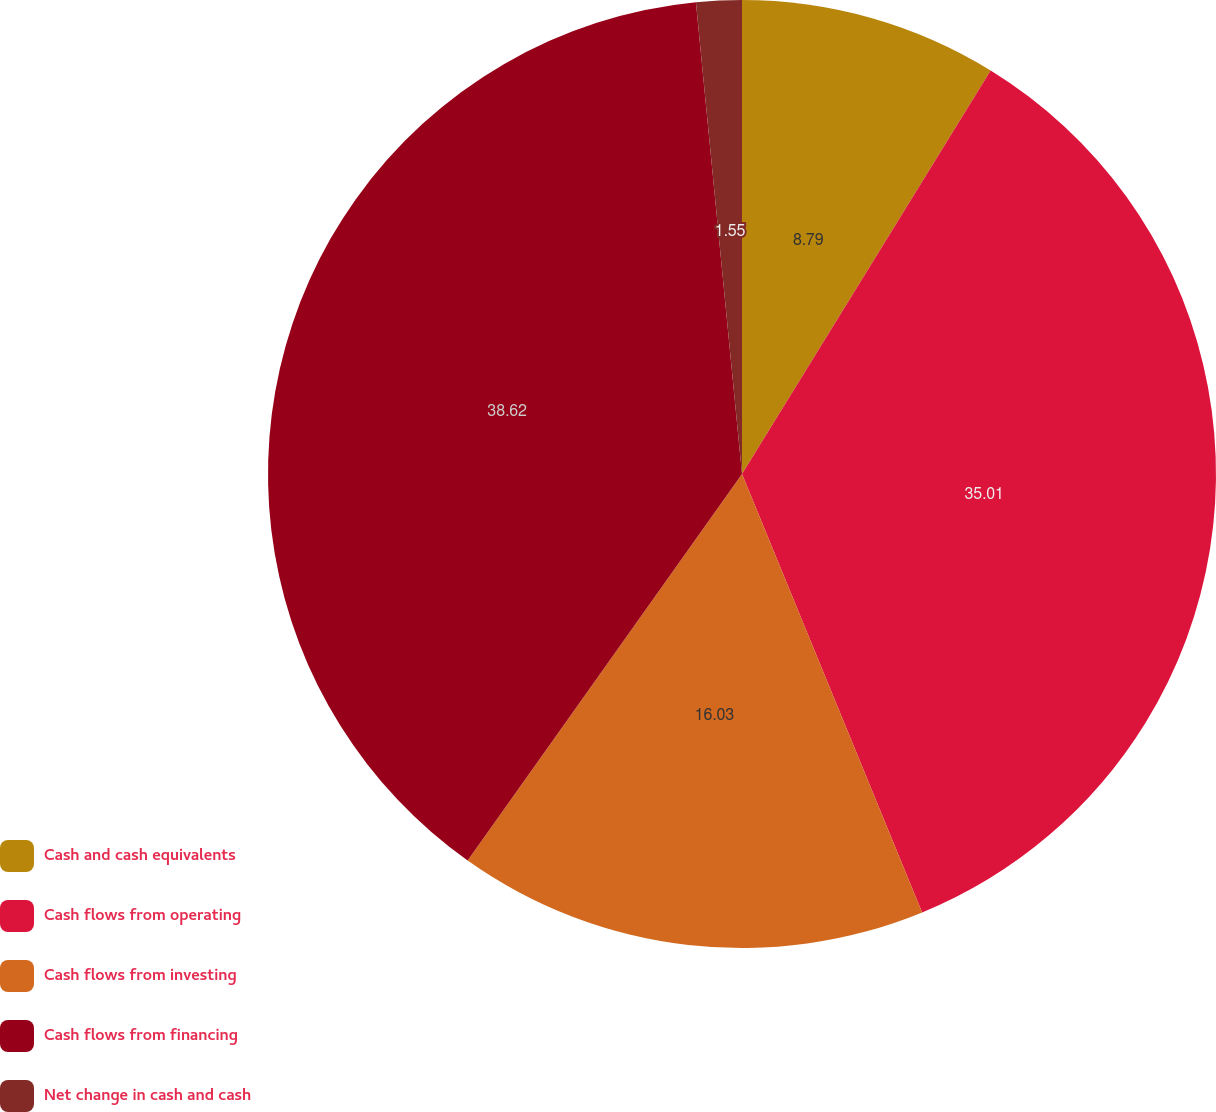Convert chart to OTSL. <chart><loc_0><loc_0><loc_500><loc_500><pie_chart><fcel>Cash and cash equivalents<fcel>Cash flows from operating<fcel>Cash flows from investing<fcel>Cash flows from financing<fcel>Net change in cash and cash<nl><fcel>8.79%<fcel>35.01%<fcel>16.03%<fcel>38.63%<fcel>1.55%<nl></chart> 